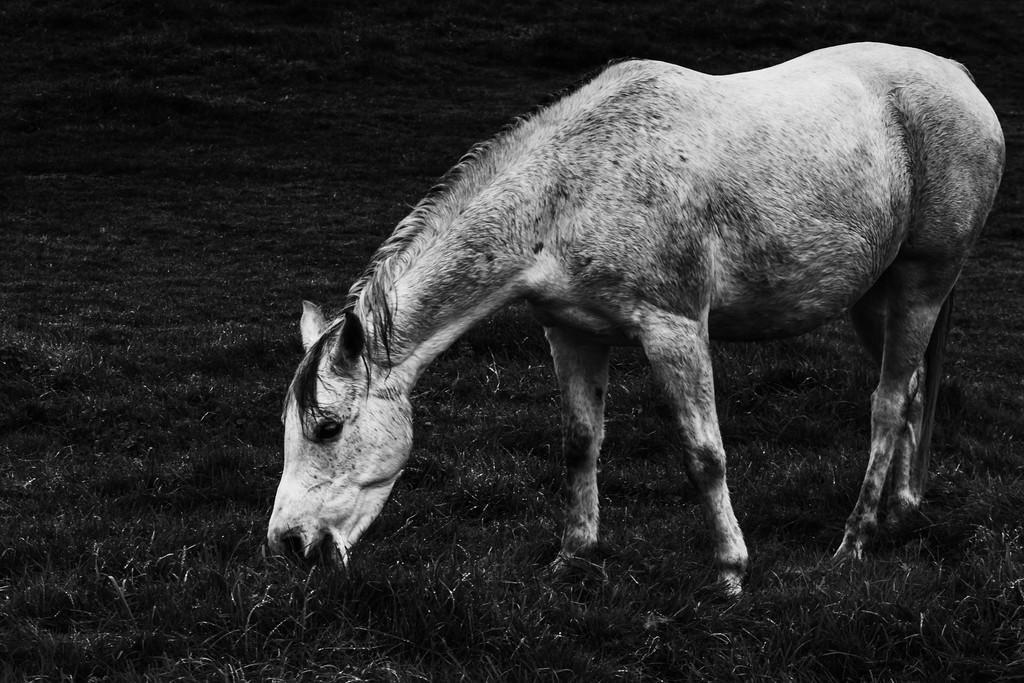Describe this image in one or two sentences. In this picture we can see a horse is eating grass. 